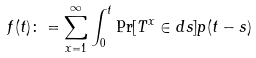<formula> <loc_0><loc_0><loc_500><loc_500>f ( t ) \colon = \sum _ { x = 1 } ^ { \infty } \int _ { 0 } ^ { t } \Pr [ T ^ { x } \in d s ] p ( t - s )</formula> 